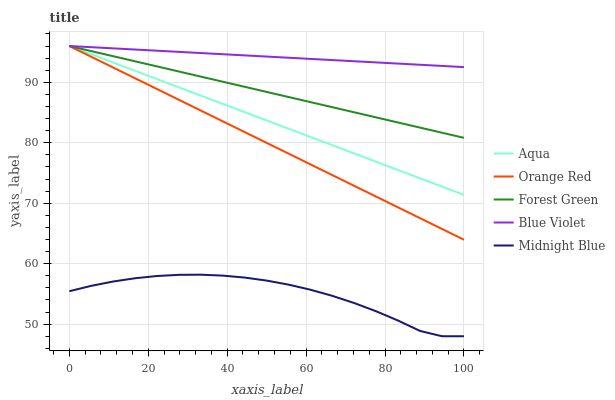Does Midnight Blue have the minimum area under the curve?
Answer yes or no. Yes. Does Blue Violet have the maximum area under the curve?
Answer yes or no. Yes. Does Aqua have the minimum area under the curve?
Answer yes or no. No. Does Aqua have the maximum area under the curve?
Answer yes or no. No. Is Blue Violet the smoothest?
Answer yes or no. Yes. Is Midnight Blue the roughest?
Answer yes or no. Yes. Is Aqua the smoothest?
Answer yes or no. No. Is Aqua the roughest?
Answer yes or no. No. Does Midnight Blue have the lowest value?
Answer yes or no. Yes. Does Aqua have the lowest value?
Answer yes or no. No. Does Blue Violet have the highest value?
Answer yes or no. Yes. Does Midnight Blue have the highest value?
Answer yes or no. No. Is Midnight Blue less than Forest Green?
Answer yes or no. Yes. Is Forest Green greater than Midnight Blue?
Answer yes or no. Yes. Does Forest Green intersect Orange Red?
Answer yes or no. Yes. Is Forest Green less than Orange Red?
Answer yes or no. No. Is Forest Green greater than Orange Red?
Answer yes or no. No. Does Midnight Blue intersect Forest Green?
Answer yes or no. No. 